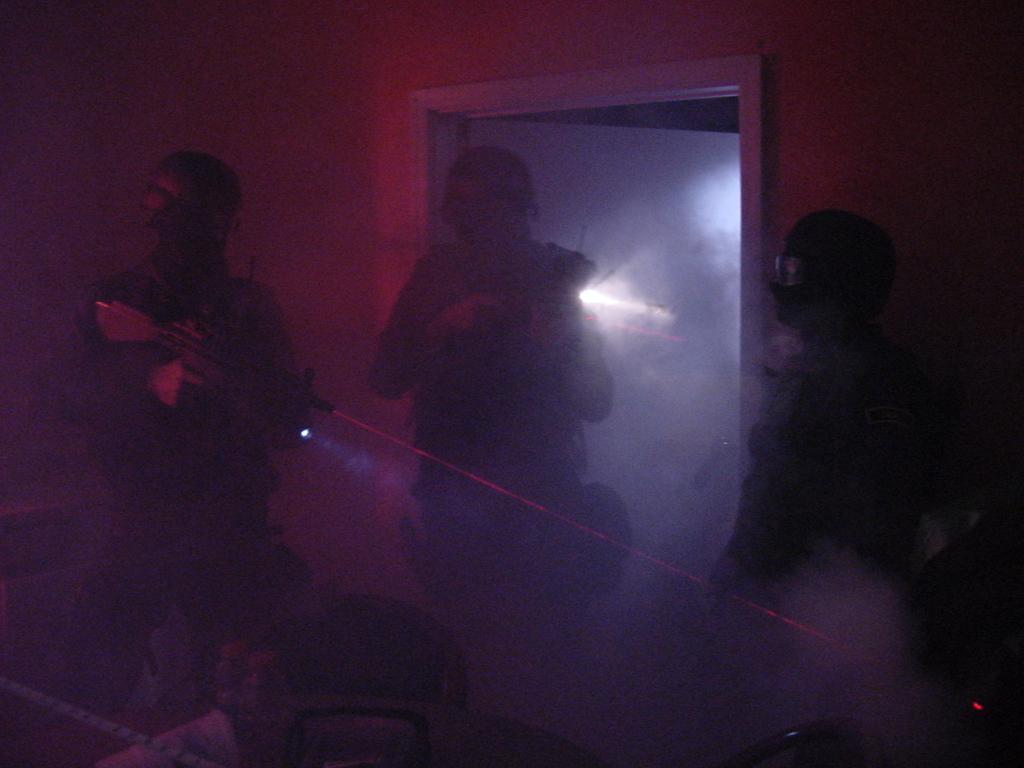Describe this image in one or two sentences. The image is taken in the room. In the center of the image we can see three people. The man standing on the left is holding a rifle. In the background there is a wall and a door. 